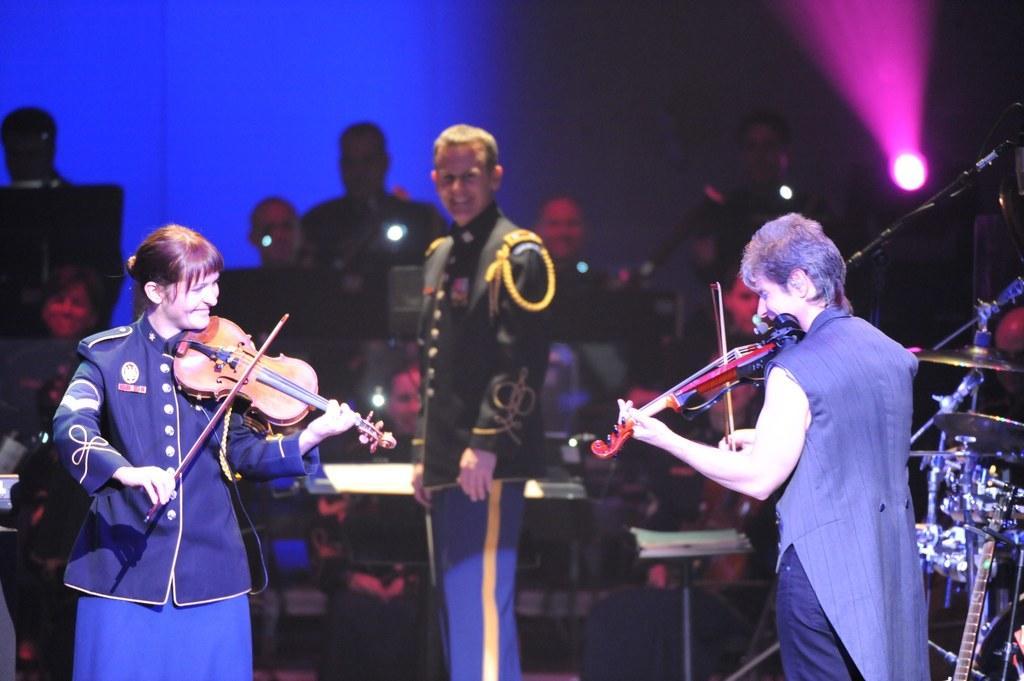Can you describe this image briefly? In the foreground of this picture we can see the two persons standing, smiling and playing violin. In the center we can see a person wearing uniform, smiling and standing. In the background we can see the group of people seems to be playing the musical instruments and we can see the focusing lights, musical instruments, microphone and some other objects. 